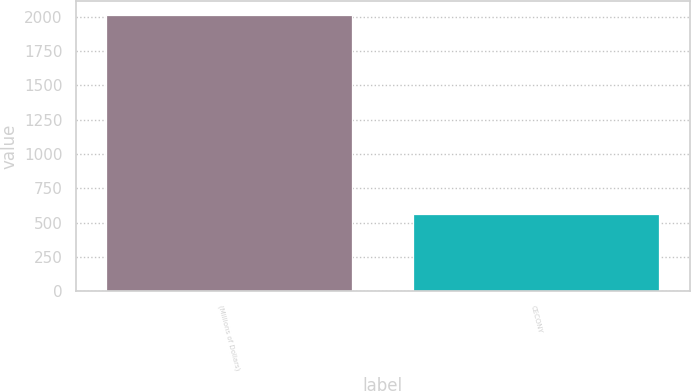Convert chart. <chart><loc_0><loc_0><loc_500><loc_500><bar_chart><fcel>(Millions of Dollars)<fcel>CECONY<nl><fcel>2015<fcel>563<nl></chart> 